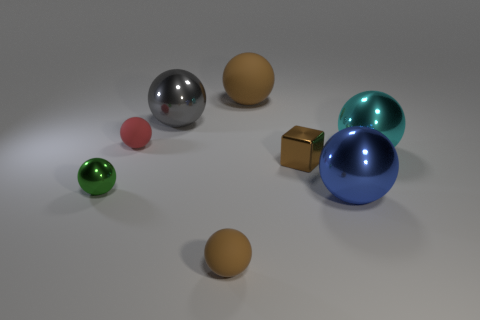There is a tiny matte ball that is in front of the small green thing; is it the same color as the big rubber object?
Make the answer very short. Yes. Is the color of the small shiny cube the same as the big matte ball?
Your answer should be compact. Yes. There is a small thing that is the same color as the block; what is its material?
Keep it short and to the point. Rubber. How many other spheres have the same color as the big matte ball?
Make the answer very short. 1. How big is the green object in front of the metallic thing behind the large cyan sphere?
Ensure brevity in your answer.  Small. How many things are small brown blocks in front of the big cyan metal object or big blue spheres?
Your answer should be very brief. 2. Is there another metallic object that has the same size as the red thing?
Ensure brevity in your answer.  Yes. There is a rubber object that is behind the gray object; is there a tiny ball that is to the right of it?
Offer a terse response. No. How many cubes are big blue metallic things or tiny brown metallic things?
Ensure brevity in your answer.  1. Are there any other big rubber things of the same shape as the big blue thing?
Give a very brief answer. Yes. 